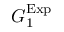<formula> <loc_0><loc_0><loc_500><loc_500>G _ { 1 } ^ { E x p }</formula> 